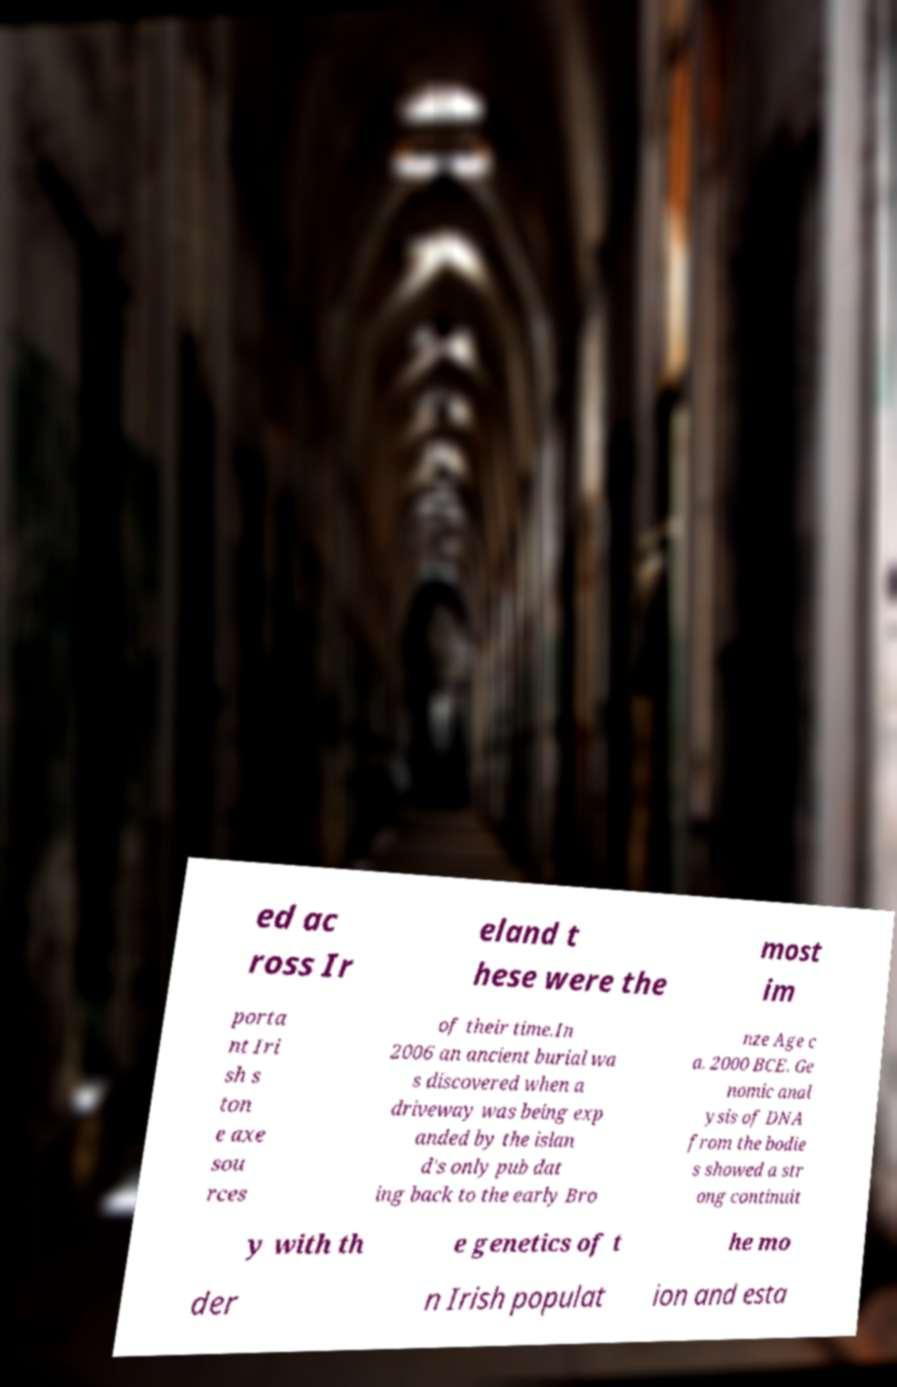There's text embedded in this image that I need extracted. Can you transcribe it verbatim? ed ac ross Ir eland t hese were the most im porta nt Iri sh s ton e axe sou rces of their time.In 2006 an ancient burial wa s discovered when a driveway was being exp anded by the islan d's only pub dat ing back to the early Bro nze Age c a. 2000 BCE. Ge nomic anal ysis of DNA from the bodie s showed a str ong continuit y with th e genetics of t he mo der n Irish populat ion and esta 